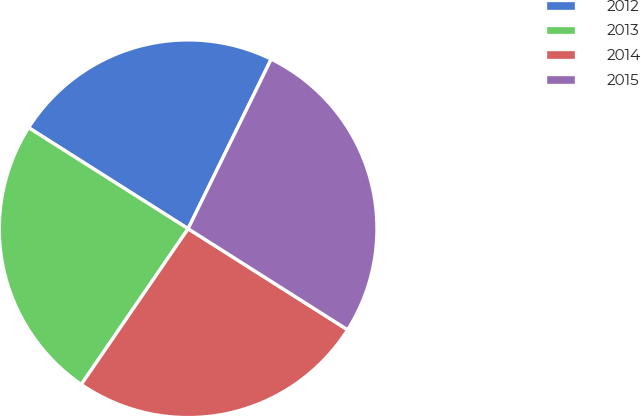Convert chart. <chart><loc_0><loc_0><loc_500><loc_500><pie_chart><fcel>2012<fcel>2013<fcel>2014<fcel>2015<nl><fcel>23.26%<fcel>24.42%<fcel>25.58%<fcel>26.74%<nl></chart> 